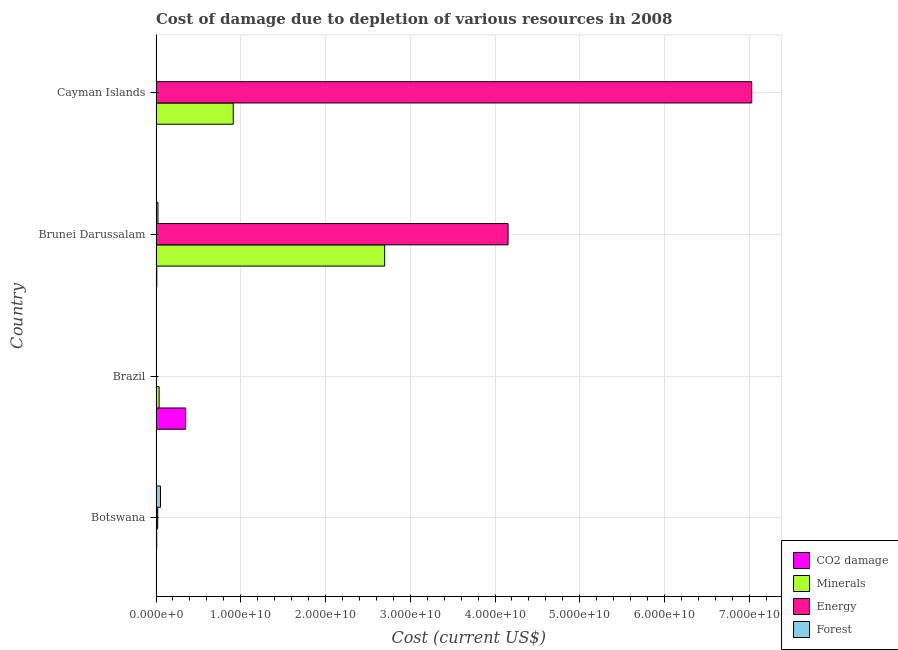How many different coloured bars are there?
Provide a short and direct response. 4. How many groups of bars are there?
Provide a succinct answer. 4. Are the number of bars per tick equal to the number of legend labels?
Offer a very short reply. Yes. How many bars are there on the 4th tick from the bottom?
Give a very brief answer. 4. What is the cost of damage due to depletion of energy in Cayman Islands?
Keep it short and to the point. 7.03e+1. Across all countries, what is the maximum cost of damage due to depletion of minerals?
Make the answer very short. 2.70e+1. Across all countries, what is the minimum cost of damage due to depletion of minerals?
Offer a very short reply. 8.10e+07. In which country was the cost of damage due to depletion of energy maximum?
Make the answer very short. Cayman Islands. In which country was the cost of damage due to depletion of coal minimum?
Your answer should be compact. Cayman Islands. What is the total cost of damage due to depletion of forests in the graph?
Offer a terse response. 7.81e+08. What is the difference between the cost of damage due to depletion of coal in Botswana and that in Brunei Darussalam?
Ensure brevity in your answer.  -4.56e+07. What is the difference between the cost of damage due to depletion of energy in Botswana and the cost of damage due to depletion of forests in Cayman Islands?
Your answer should be very brief. 1.83e+08. What is the average cost of damage due to depletion of coal per country?
Give a very brief answer. 9.10e+08. What is the difference between the cost of damage due to depletion of coal and cost of damage due to depletion of forests in Brunei Darussalam?
Ensure brevity in your answer.  -1.40e+08. What is the ratio of the cost of damage due to depletion of coal in Botswana to that in Cayman Islands?
Offer a terse response. 8.38. What is the difference between the highest and the second highest cost of damage due to depletion of minerals?
Keep it short and to the point. 1.79e+1. What is the difference between the highest and the lowest cost of damage due to depletion of forests?
Give a very brief answer. 5.23e+08. Is it the case that in every country, the sum of the cost of damage due to depletion of energy and cost of damage due to depletion of minerals is greater than the sum of cost of damage due to depletion of coal and cost of damage due to depletion of forests?
Keep it short and to the point. No. What does the 2nd bar from the top in Botswana represents?
Make the answer very short. Energy. What does the 4th bar from the bottom in Cayman Islands represents?
Give a very brief answer. Forest. Is it the case that in every country, the sum of the cost of damage due to depletion of coal and cost of damage due to depletion of minerals is greater than the cost of damage due to depletion of energy?
Make the answer very short. No. How many bars are there?
Make the answer very short. 16. Are all the bars in the graph horizontal?
Offer a very short reply. Yes. What is the difference between two consecutive major ticks on the X-axis?
Offer a very short reply. 1.00e+1. Does the graph contain grids?
Offer a very short reply. Yes. What is the title of the graph?
Offer a terse response. Cost of damage due to depletion of various resources in 2008 . Does "Social Awareness" appear as one of the legend labels in the graph?
Ensure brevity in your answer.  No. What is the label or title of the X-axis?
Your answer should be compact. Cost (current US$). What is the label or title of the Y-axis?
Offer a terse response. Country. What is the Cost (current US$) of CO2 damage in Botswana?
Your answer should be compact. 4.49e+07. What is the Cost (current US$) in Minerals in Botswana?
Give a very brief answer. 8.10e+07. What is the Cost (current US$) of Energy in Botswana?
Your response must be concise. 1.99e+08. What is the Cost (current US$) of Forest in Botswana?
Your response must be concise. 5.28e+08. What is the Cost (current US$) of CO2 damage in Brazil?
Your response must be concise. 3.50e+09. What is the Cost (current US$) in Minerals in Brazil?
Offer a very short reply. 3.66e+08. What is the Cost (current US$) in Energy in Brazil?
Provide a short and direct response. 3.07e+07. What is the Cost (current US$) in Forest in Brazil?
Your response must be concise. 5.44e+06. What is the Cost (current US$) of CO2 damage in Brunei Darussalam?
Keep it short and to the point. 9.05e+07. What is the Cost (current US$) in Minerals in Brunei Darussalam?
Offer a very short reply. 2.70e+1. What is the Cost (current US$) of Energy in Brunei Darussalam?
Offer a very short reply. 4.15e+1. What is the Cost (current US$) of Forest in Brunei Darussalam?
Ensure brevity in your answer.  2.31e+08. What is the Cost (current US$) in CO2 damage in Cayman Islands?
Keep it short and to the point. 5.36e+06. What is the Cost (current US$) in Minerals in Cayman Islands?
Ensure brevity in your answer.  9.12e+09. What is the Cost (current US$) of Energy in Cayman Islands?
Your answer should be very brief. 7.03e+1. What is the Cost (current US$) of Forest in Cayman Islands?
Your answer should be very brief. 1.58e+07. Across all countries, what is the maximum Cost (current US$) of CO2 damage?
Make the answer very short. 3.50e+09. Across all countries, what is the maximum Cost (current US$) of Minerals?
Give a very brief answer. 2.70e+1. Across all countries, what is the maximum Cost (current US$) of Energy?
Offer a very short reply. 7.03e+1. Across all countries, what is the maximum Cost (current US$) of Forest?
Make the answer very short. 5.28e+08. Across all countries, what is the minimum Cost (current US$) in CO2 damage?
Your answer should be compact. 5.36e+06. Across all countries, what is the minimum Cost (current US$) in Minerals?
Ensure brevity in your answer.  8.10e+07. Across all countries, what is the minimum Cost (current US$) of Energy?
Give a very brief answer. 3.07e+07. Across all countries, what is the minimum Cost (current US$) in Forest?
Offer a terse response. 5.44e+06. What is the total Cost (current US$) in CO2 damage in the graph?
Provide a succinct answer. 3.64e+09. What is the total Cost (current US$) of Minerals in the graph?
Provide a succinct answer. 3.65e+1. What is the total Cost (current US$) in Energy in the graph?
Provide a short and direct response. 1.12e+11. What is the total Cost (current US$) in Forest in the graph?
Your answer should be compact. 7.81e+08. What is the difference between the Cost (current US$) in CO2 damage in Botswana and that in Brazil?
Ensure brevity in your answer.  -3.45e+09. What is the difference between the Cost (current US$) in Minerals in Botswana and that in Brazil?
Provide a short and direct response. -2.85e+08. What is the difference between the Cost (current US$) in Energy in Botswana and that in Brazil?
Make the answer very short. 1.68e+08. What is the difference between the Cost (current US$) of Forest in Botswana and that in Brazil?
Provide a short and direct response. 5.23e+08. What is the difference between the Cost (current US$) of CO2 damage in Botswana and that in Brunei Darussalam?
Your response must be concise. -4.56e+07. What is the difference between the Cost (current US$) of Minerals in Botswana and that in Brunei Darussalam?
Ensure brevity in your answer.  -2.69e+1. What is the difference between the Cost (current US$) of Energy in Botswana and that in Brunei Darussalam?
Keep it short and to the point. -4.13e+1. What is the difference between the Cost (current US$) of Forest in Botswana and that in Brunei Darussalam?
Your answer should be compact. 2.97e+08. What is the difference between the Cost (current US$) of CO2 damage in Botswana and that in Cayman Islands?
Your answer should be compact. 3.96e+07. What is the difference between the Cost (current US$) in Minerals in Botswana and that in Cayman Islands?
Offer a very short reply. -9.04e+09. What is the difference between the Cost (current US$) of Energy in Botswana and that in Cayman Islands?
Your answer should be very brief. -7.01e+1. What is the difference between the Cost (current US$) of Forest in Botswana and that in Cayman Islands?
Your answer should be very brief. 5.13e+08. What is the difference between the Cost (current US$) of CO2 damage in Brazil and that in Brunei Darussalam?
Your answer should be compact. 3.41e+09. What is the difference between the Cost (current US$) in Minerals in Brazil and that in Brunei Darussalam?
Give a very brief answer. -2.66e+1. What is the difference between the Cost (current US$) in Energy in Brazil and that in Brunei Darussalam?
Your answer should be very brief. -4.15e+1. What is the difference between the Cost (current US$) of Forest in Brazil and that in Brunei Darussalam?
Provide a short and direct response. -2.26e+08. What is the difference between the Cost (current US$) in CO2 damage in Brazil and that in Cayman Islands?
Make the answer very short. 3.49e+09. What is the difference between the Cost (current US$) of Minerals in Brazil and that in Cayman Islands?
Your answer should be very brief. -8.75e+09. What is the difference between the Cost (current US$) of Energy in Brazil and that in Cayman Islands?
Your answer should be compact. -7.03e+1. What is the difference between the Cost (current US$) of Forest in Brazil and that in Cayman Islands?
Provide a succinct answer. -1.04e+07. What is the difference between the Cost (current US$) in CO2 damage in Brunei Darussalam and that in Cayman Islands?
Provide a succinct answer. 8.51e+07. What is the difference between the Cost (current US$) of Minerals in Brunei Darussalam and that in Cayman Islands?
Keep it short and to the point. 1.79e+1. What is the difference between the Cost (current US$) in Energy in Brunei Darussalam and that in Cayman Islands?
Give a very brief answer. -2.88e+1. What is the difference between the Cost (current US$) in Forest in Brunei Darussalam and that in Cayman Islands?
Your response must be concise. 2.15e+08. What is the difference between the Cost (current US$) of CO2 damage in Botswana and the Cost (current US$) of Minerals in Brazil?
Offer a very short reply. -3.21e+08. What is the difference between the Cost (current US$) of CO2 damage in Botswana and the Cost (current US$) of Energy in Brazil?
Your response must be concise. 1.42e+07. What is the difference between the Cost (current US$) in CO2 damage in Botswana and the Cost (current US$) in Forest in Brazil?
Provide a succinct answer. 3.95e+07. What is the difference between the Cost (current US$) of Minerals in Botswana and the Cost (current US$) of Energy in Brazil?
Keep it short and to the point. 5.03e+07. What is the difference between the Cost (current US$) in Minerals in Botswana and the Cost (current US$) in Forest in Brazil?
Offer a terse response. 7.56e+07. What is the difference between the Cost (current US$) of Energy in Botswana and the Cost (current US$) of Forest in Brazil?
Keep it short and to the point. 1.93e+08. What is the difference between the Cost (current US$) of CO2 damage in Botswana and the Cost (current US$) of Minerals in Brunei Darussalam?
Your answer should be very brief. -2.69e+1. What is the difference between the Cost (current US$) in CO2 damage in Botswana and the Cost (current US$) in Energy in Brunei Darussalam?
Ensure brevity in your answer.  -4.15e+1. What is the difference between the Cost (current US$) of CO2 damage in Botswana and the Cost (current US$) of Forest in Brunei Darussalam?
Make the answer very short. -1.86e+08. What is the difference between the Cost (current US$) in Minerals in Botswana and the Cost (current US$) in Energy in Brunei Darussalam?
Keep it short and to the point. -4.15e+1. What is the difference between the Cost (current US$) in Minerals in Botswana and the Cost (current US$) in Forest in Brunei Darussalam?
Give a very brief answer. -1.50e+08. What is the difference between the Cost (current US$) in Energy in Botswana and the Cost (current US$) in Forest in Brunei Darussalam?
Make the answer very short. -3.23e+07. What is the difference between the Cost (current US$) in CO2 damage in Botswana and the Cost (current US$) in Minerals in Cayman Islands?
Make the answer very short. -9.07e+09. What is the difference between the Cost (current US$) of CO2 damage in Botswana and the Cost (current US$) of Energy in Cayman Islands?
Provide a short and direct response. -7.02e+1. What is the difference between the Cost (current US$) in CO2 damage in Botswana and the Cost (current US$) in Forest in Cayman Islands?
Provide a short and direct response. 2.91e+07. What is the difference between the Cost (current US$) of Minerals in Botswana and the Cost (current US$) of Energy in Cayman Islands?
Keep it short and to the point. -7.02e+1. What is the difference between the Cost (current US$) in Minerals in Botswana and the Cost (current US$) in Forest in Cayman Islands?
Make the answer very short. 6.52e+07. What is the difference between the Cost (current US$) of Energy in Botswana and the Cost (current US$) of Forest in Cayman Islands?
Ensure brevity in your answer.  1.83e+08. What is the difference between the Cost (current US$) in CO2 damage in Brazil and the Cost (current US$) in Minerals in Brunei Darussalam?
Offer a terse response. -2.35e+1. What is the difference between the Cost (current US$) in CO2 damage in Brazil and the Cost (current US$) in Energy in Brunei Darussalam?
Your response must be concise. -3.80e+1. What is the difference between the Cost (current US$) in CO2 damage in Brazil and the Cost (current US$) in Forest in Brunei Darussalam?
Keep it short and to the point. 3.27e+09. What is the difference between the Cost (current US$) of Minerals in Brazil and the Cost (current US$) of Energy in Brunei Darussalam?
Make the answer very short. -4.12e+1. What is the difference between the Cost (current US$) in Minerals in Brazil and the Cost (current US$) in Forest in Brunei Darussalam?
Provide a succinct answer. 1.35e+08. What is the difference between the Cost (current US$) in Energy in Brazil and the Cost (current US$) in Forest in Brunei Darussalam?
Keep it short and to the point. -2.00e+08. What is the difference between the Cost (current US$) of CO2 damage in Brazil and the Cost (current US$) of Minerals in Cayman Islands?
Your response must be concise. -5.62e+09. What is the difference between the Cost (current US$) in CO2 damage in Brazil and the Cost (current US$) in Energy in Cayman Islands?
Your response must be concise. -6.68e+1. What is the difference between the Cost (current US$) in CO2 damage in Brazil and the Cost (current US$) in Forest in Cayman Islands?
Give a very brief answer. 3.48e+09. What is the difference between the Cost (current US$) in Minerals in Brazil and the Cost (current US$) in Energy in Cayman Islands?
Provide a succinct answer. -6.99e+1. What is the difference between the Cost (current US$) in Minerals in Brazil and the Cost (current US$) in Forest in Cayman Islands?
Offer a very short reply. 3.50e+08. What is the difference between the Cost (current US$) of Energy in Brazil and the Cost (current US$) of Forest in Cayman Islands?
Provide a short and direct response. 1.49e+07. What is the difference between the Cost (current US$) of CO2 damage in Brunei Darussalam and the Cost (current US$) of Minerals in Cayman Islands?
Make the answer very short. -9.03e+09. What is the difference between the Cost (current US$) in CO2 damage in Brunei Darussalam and the Cost (current US$) in Energy in Cayman Islands?
Ensure brevity in your answer.  -7.02e+1. What is the difference between the Cost (current US$) in CO2 damage in Brunei Darussalam and the Cost (current US$) in Forest in Cayman Islands?
Provide a succinct answer. 7.47e+07. What is the difference between the Cost (current US$) of Minerals in Brunei Darussalam and the Cost (current US$) of Energy in Cayman Islands?
Offer a very short reply. -4.33e+1. What is the difference between the Cost (current US$) in Minerals in Brunei Darussalam and the Cost (current US$) in Forest in Cayman Islands?
Make the answer very short. 2.70e+1. What is the difference between the Cost (current US$) of Energy in Brunei Darussalam and the Cost (current US$) of Forest in Cayman Islands?
Provide a succinct answer. 4.15e+1. What is the average Cost (current US$) of CO2 damage per country?
Offer a very short reply. 9.10e+08. What is the average Cost (current US$) of Minerals per country?
Your answer should be very brief. 9.14e+09. What is the average Cost (current US$) of Energy per country?
Provide a succinct answer. 2.80e+1. What is the average Cost (current US$) of Forest per country?
Ensure brevity in your answer.  1.95e+08. What is the difference between the Cost (current US$) of CO2 damage and Cost (current US$) of Minerals in Botswana?
Your answer should be compact. -3.61e+07. What is the difference between the Cost (current US$) of CO2 damage and Cost (current US$) of Energy in Botswana?
Offer a very short reply. -1.54e+08. What is the difference between the Cost (current US$) in CO2 damage and Cost (current US$) in Forest in Botswana?
Keep it short and to the point. -4.84e+08. What is the difference between the Cost (current US$) of Minerals and Cost (current US$) of Energy in Botswana?
Provide a short and direct response. -1.18e+08. What is the difference between the Cost (current US$) of Minerals and Cost (current US$) of Forest in Botswana?
Provide a short and direct response. -4.47e+08. What is the difference between the Cost (current US$) in Energy and Cost (current US$) in Forest in Botswana?
Your response must be concise. -3.30e+08. What is the difference between the Cost (current US$) of CO2 damage and Cost (current US$) of Minerals in Brazil?
Your answer should be compact. 3.13e+09. What is the difference between the Cost (current US$) in CO2 damage and Cost (current US$) in Energy in Brazil?
Provide a short and direct response. 3.47e+09. What is the difference between the Cost (current US$) in CO2 damage and Cost (current US$) in Forest in Brazil?
Keep it short and to the point. 3.49e+09. What is the difference between the Cost (current US$) in Minerals and Cost (current US$) in Energy in Brazil?
Your response must be concise. 3.35e+08. What is the difference between the Cost (current US$) in Minerals and Cost (current US$) in Forest in Brazil?
Provide a short and direct response. 3.60e+08. What is the difference between the Cost (current US$) in Energy and Cost (current US$) in Forest in Brazil?
Make the answer very short. 2.53e+07. What is the difference between the Cost (current US$) in CO2 damage and Cost (current US$) in Minerals in Brunei Darussalam?
Provide a succinct answer. -2.69e+1. What is the difference between the Cost (current US$) of CO2 damage and Cost (current US$) of Energy in Brunei Darussalam?
Offer a terse response. -4.15e+1. What is the difference between the Cost (current US$) of CO2 damage and Cost (current US$) of Forest in Brunei Darussalam?
Provide a succinct answer. -1.40e+08. What is the difference between the Cost (current US$) in Minerals and Cost (current US$) in Energy in Brunei Darussalam?
Provide a succinct answer. -1.46e+1. What is the difference between the Cost (current US$) in Minerals and Cost (current US$) in Forest in Brunei Darussalam?
Your answer should be very brief. 2.68e+1. What is the difference between the Cost (current US$) of Energy and Cost (current US$) of Forest in Brunei Darussalam?
Offer a terse response. 4.13e+1. What is the difference between the Cost (current US$) of CO2 damage and Cost (current US$) of Minerals in Cayman Islands?
Keep it short and to the point. -9.11e+09. What is the difference between the Cost (current US$) of CO2 damage and Cost (current US$) of Energy in Cayman Islands?
Your answer should be very brief. -7.03e+1. What is the difference between the Cost (current US$) in CO2 damage and Cost (current US$) in Forest in Cayman Islands?
Provide a short and direct response. -1.05e+07. What is the difference between the Cost (current US$) of Minerals and Cost (current US$) of Energy in Cayman Islands?
Keep it short and to the point. -6.12e+1. What is the difference between the Cost (current US$) of Minerals and Cost (current US$) of Forest in Cayman Islands?
Your response must be concise. 9.10e+09. What is the difference between the Cost (current US$) in Energy and Cost (current US$) in Forest in Cayman Islands?
Give a very brief answer. 7.03e+1. What is the ratio of the Cost (current US$) in CO2 damage in Botswana to that in Brazil?
Give a very brief answer. 0.01. What is the ratio of the Cost (current US$) in Minerals in Botswana to that in Brazil?
Keep it short and to the point. 0.22. What is the ratio of the Cost (current US$) of Energy in Botswana to that in Brazil?
Keep it short and to the point. 6.47. What is the ratio of the Cost (current US$) in Forest in Botswana to that in Brazil?
Make the answer very short. 97.21. What is the ratio of the Cost (current US$) in CO2 damage in Botswana to that in Brunei Darussalam?
Offer a terse response. 0.5. What is the ratio of the Cost (current US$) in Minerals in Botswana to that in Brunei Darussalam?
Offer a very short reply. 0. What is the ratio of the Cost (current US$) in Energy in Botswana to that in Brunei Darussalam?
Offer a terse response. 0. What is the ratio of the Cost (current US$) of Forest in Botswana to that in Brunei Darussalam?
Give a very brief answer. 2.29. What is the ratio of the Cost (current US$) in CO2 damage in Botswana to that in Cayman Islands?
Ensure brevity in your answer.  8.38. What is the ratio of the Cost (current US$) of Minerals in Botswana to that in Cayman Islands?
Offer a terse response. 0.01. What is the ratio of the Cost (current US$) of Energy in Botswana to that in Cayman Islands?
Offer a terse response. 0. What is the ratio of the Cost (current US$) in Forest in Botswana to that in Cayman Islands?
Make the answer very short. 33.37. What is the ratio of the Cost (current US$) of CO2 damage in Brazil to that in Brunei Darussalam?
Provide a short and direct response. 38.65. What is the ratio of the Cost (current US$) of Minerals in Brazil to that in Brunei Darussalam?
Provide a succinct answer. 0.01. What is the ratio of the Cost (current US$) of Energy in Brazil to that in Brunei Darussalam?
Your answer should be compact. 0. What is the ratio of the Cost (current US$) in Forest in Brazil to that in Brunei Darussalam?
Your answer should be very brief. 0.02. What is the ratio of the Cost (current US$) in CO2 damage in Brazil to that in Cayman Islands?
Your response must be concise. 652.59. What is the ratio of the Cost (current US$) of Minerals in Brazil to that in Cayman Islands?
Your answer should be very brief. 0.04. What is the ratio of the Cost (current US$) in Energy in Brazil to that in Cayman Islands?
Make the answer very short. 0. What is the ratio of the Cost (current US$) of Forest in Brazil to that in Cayman Islands?
Your answer should be very brief. 0.34. What is the ratio of the Cost (current US$) in CO2 damage in Brunei Darussalam to that in Cayman Islands?
Give a very brief answer. 16.88. What is the ratio of the Cost (current US$) of Minerals in Brunei Darussalam to that in Cayman Islands?
Your answer should be compact. 2.96. What is the ratio of the Cost (current US$) of Energy in Brunei Darussalam to that in Cayman Islands?
Offer a very short reply. 0.59. What is the ratio of the Cost (current US$) in Forest in Brunei Darussalam to that in Cayman Islands?
Your answer should be very brief. 14.59. What is the difference between the highest and the second highest Cost (current US$) of CO2 damage?
Offer a very short reply. 3.41e+09. What is the difference between the highest and the second highest Cost (current US$) in Minerals?
Offer a terse response. 1.79e+1. What is the difference between the highest and the second highest Cost (current US$) of Energy?
Provide a short and direct response. 2.88e+1. What is the difference between the highest and the second highest Cost (current US$) of Forest?
Offer a terse response. 2.97e+08. What is the difference between the highest and the lowest Cost (current US$) of CO2 damage?
Offer a very short reply. 3.49e+09. What is the difference between the highest and the lowest Cost (current US$) in Minerals?
Offer a very short reply. 2.69e+1. What is the difference between the highest and the lowest Cost (current US$) in Energy?
Provide a succinct answer. 7.03e+1. What is the difference between the highest and the lowest Cost (current US$) in Forest?
Offer a very short reply. 5.23e+08. 